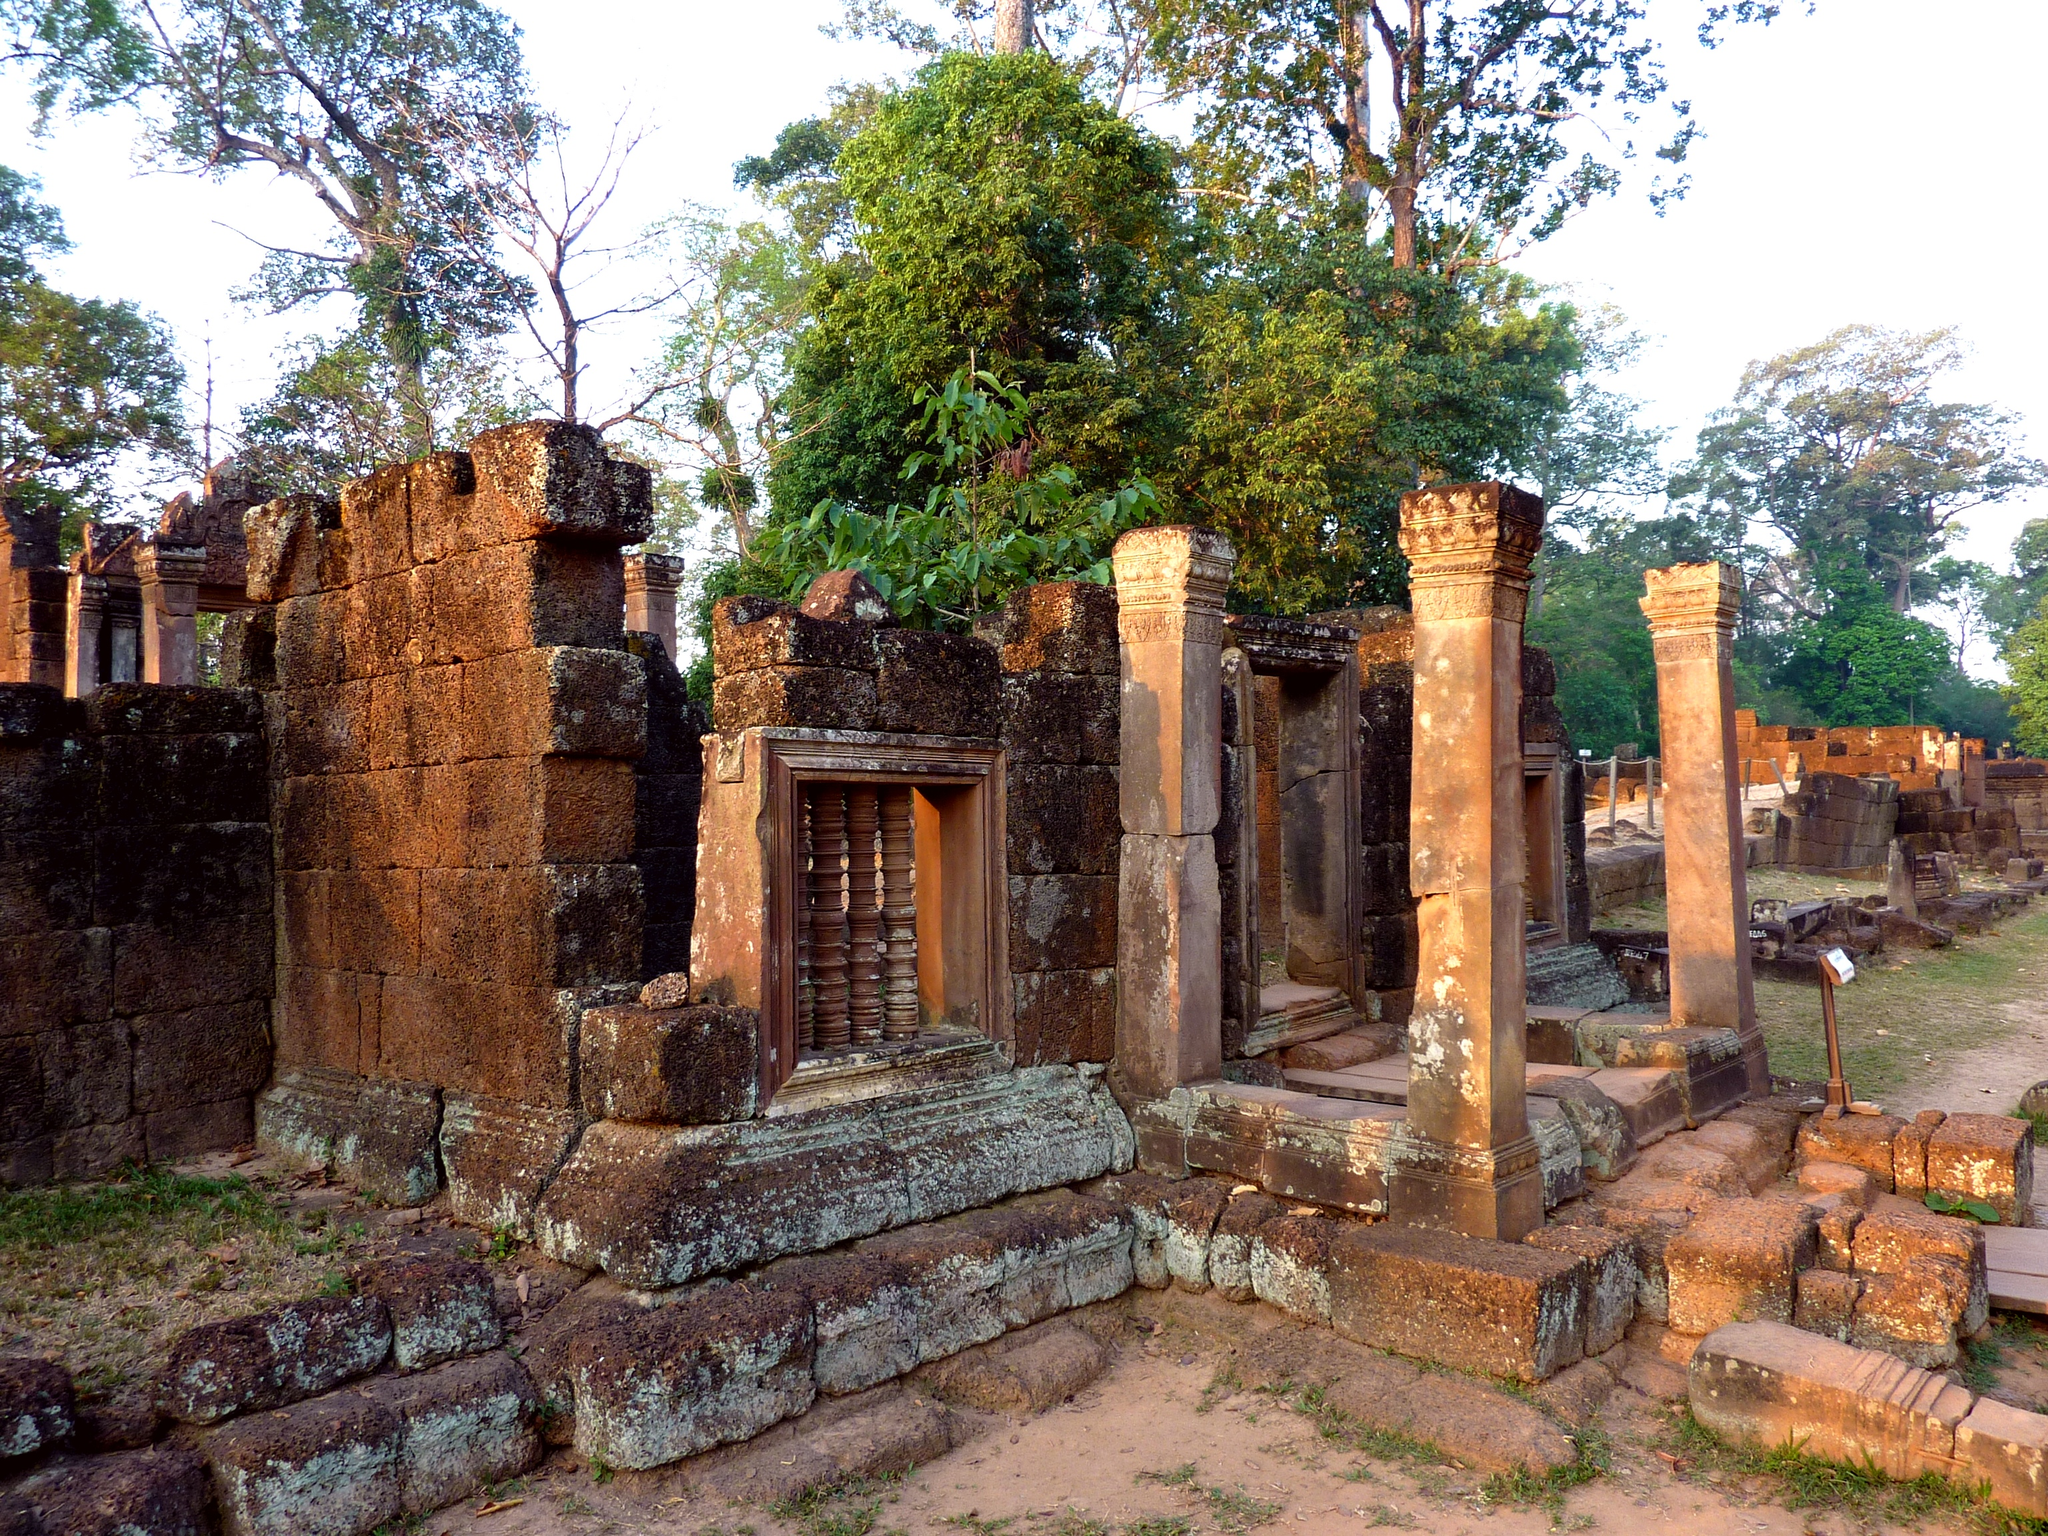Could you give a brief overview of what you see in this image? In this image I can see walls and pillars in brown color, trees in green color and the sky is in white color. 